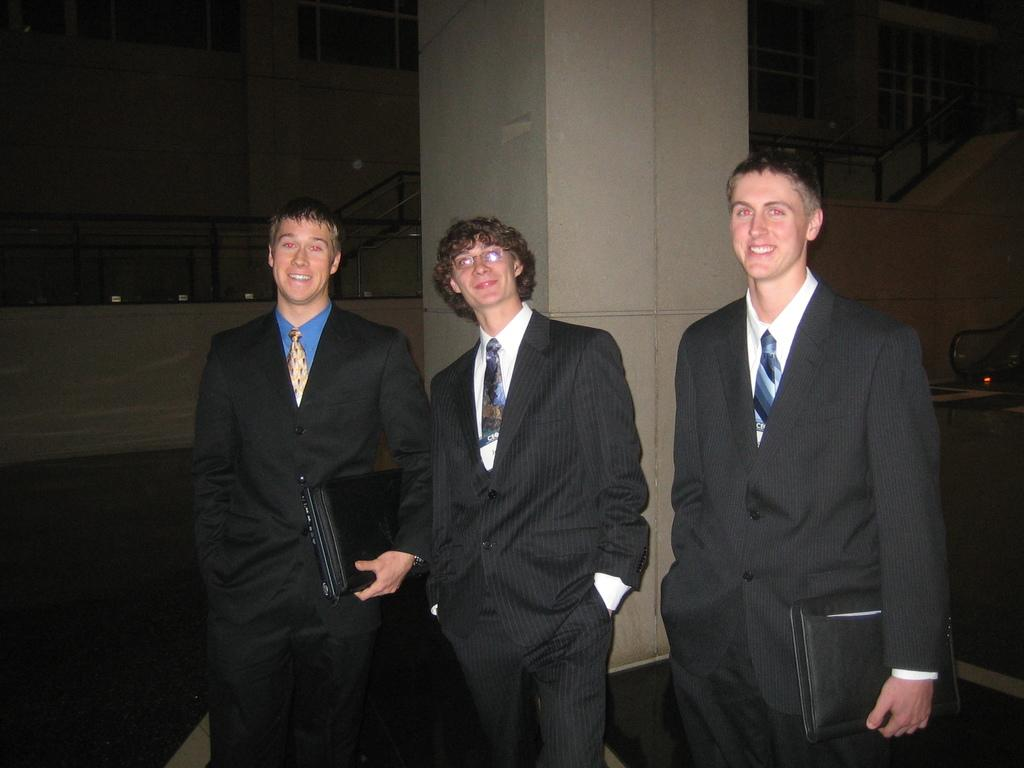How many people are in the image? There are three persons standing in the image. Where are the persons located in the image? The persons are at the bottom of the image. What can be seen in the middle of the image? There is a pillar in the middle of the image. What is visible in the background of the image? There is a wall in the background of the image. What type of ring can be seen on the middle person's finger in the image? There is no ring visible on any person's finger in the image. What is being carried in the basket by the persons in the image? There is no basket present in the image; the persons are not carrying anything. 